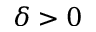<formula> <loc_0><loc_0><loc_500><loc_500>\delta > 0</formula> 